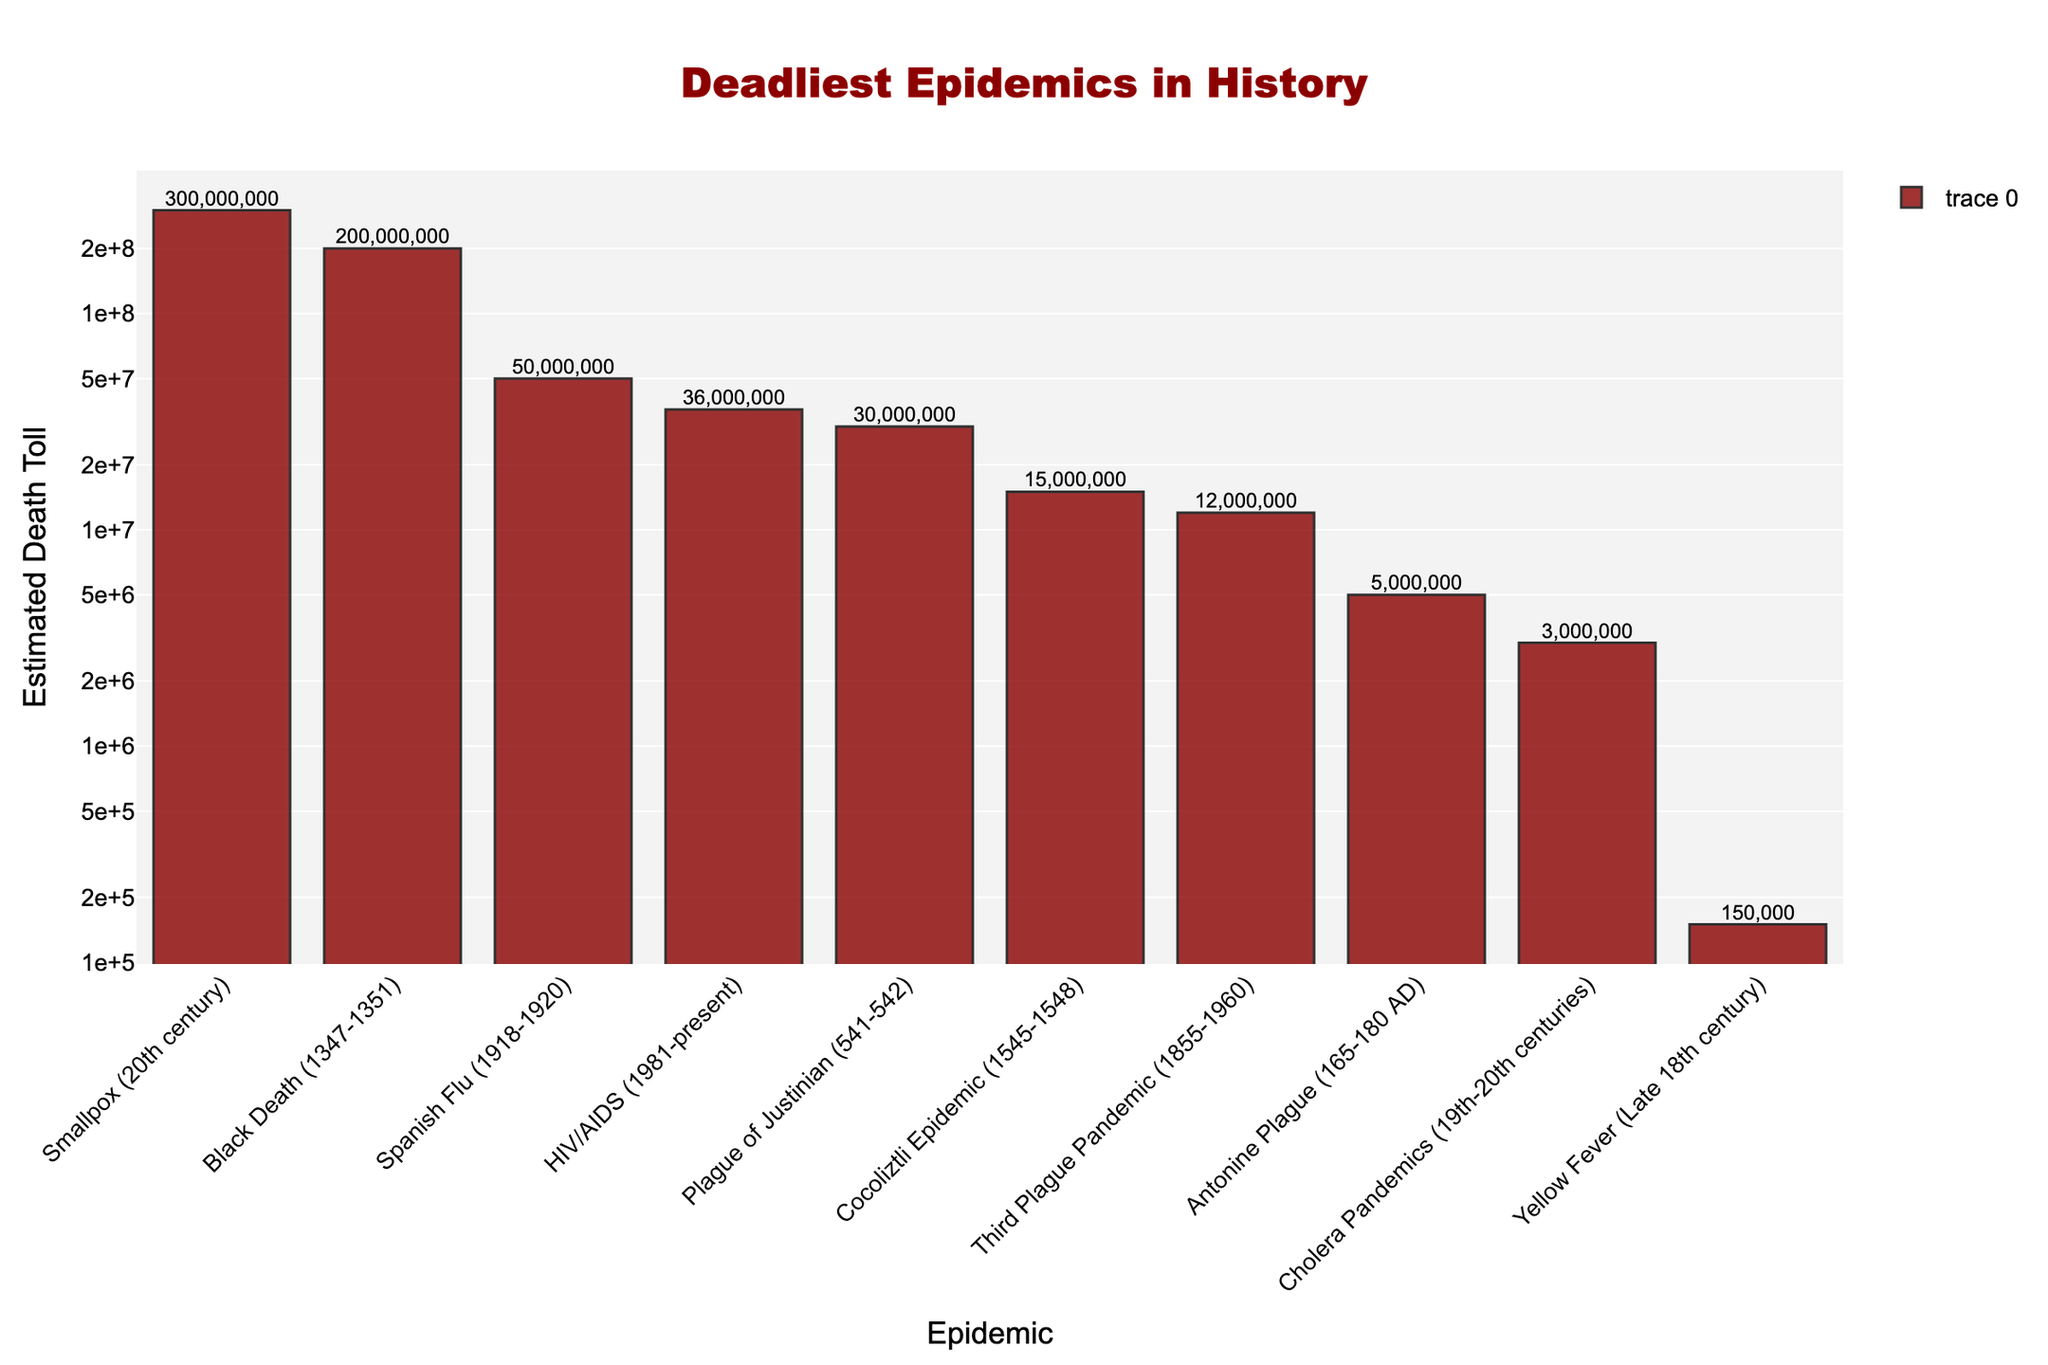what are the top three deadliest epidemics depicted in the bar chart? The estimated death tolls plotted on the bar chart show that the deadliest epidemic by far is Smallpox (20th century) with approximately 300 million deaths, followed by the Black Death (1347-1351) with about 200 million deaths, and the Spanish Flu (1918-1920) with around 50 million deaths.
Answer: Smallpox, Black Death, Spanish Flu Which epidemic has the smallest estimated death toll, and what is that death toll? The Yellow Fever (Late 18th century) epidemic has the smallest estimated death toll depicted in the bar chart, with approximately 150,000 deaths.
Answer: Yellow Fever, 150,000 How many total deaths are estimated for the Third Plague Pandemic and HIV/AIDS combined? According to the bar chart, the Third Plague Pandemic has an estimated death toll of 12 million, and HIV/AIDS has an estimated death toll of 36 million. Their combined total would be 12 million + 36 million = 48 million.
Answer: 48 million Among the depicted epidemics, which one has a death toll close to 30 million? The Plague of Justinian (541-542) has an estimated death toll of 30 million, according to the bar chart.
Answer: Plague of Justinian How does the death toll of the Antonine Plague compare to that of the Cocoliztli Epidemic? The estimated death toll for the Antonine Plague (5 million) is lower than the death toll for the Cocoliztli Epidemic (15 million) according to the bar chart.
Answer: Antonine Plague death toll is lower What is the combined death toll of all the depicted epidemics according to the bar chart? To find the combined death toll, sum the estimated death tolls of each epidemic: 300,000,000 (Smallpox) + 200,000,000 (Black Death) + 50,000,000 (Spanish Flu) + 36,000,000 (HIV/AIDS) + 30,000,000 (Plague of Justinian) + 15,000,000 (Cocoliztli Epidemic) + 12,000,000 (Third Plague Pandemic) + 5,000,000 (Antonine Plague) + 3,000,000 (Cholera Pandemics) + 150,000 (Yellow Fever). The total is 651,150,000.
Answer: 651,150,000 Which epidemic between the Black Death and the Third Plague Pandemic has a greater death toll? The Black Death has a greater estimated death toll (200 million) compared to the Third Plague Pandemic (12 million) according to the bar chart.
Answer: Black Death What color are the bars in the chart and what does that suggest given the subject matter? The bars in the chart are dark red, a color that often symbolizes death, danger, or blood, fitting the macabre and horror theme of depicting deadly epidemics.
Answer: Dark red How does the death toll of Cholera Pandemics compare with that of the Antonine Plague? The bar chart shows that the Cholera Pandemics have an estimated death toll of 3 million, which is less than the Antonine Plague’s estimated toll of 5 million.
Answer: Cholera Pandemics death toll is lower What visual element has been added to the bar chart to enhance its morbid theme? The chart includes skull shapes placed next to each bar, adding a sinister and morbid touch to the depiction of death tolls from various epidemics.
Answer: Skull shapes 